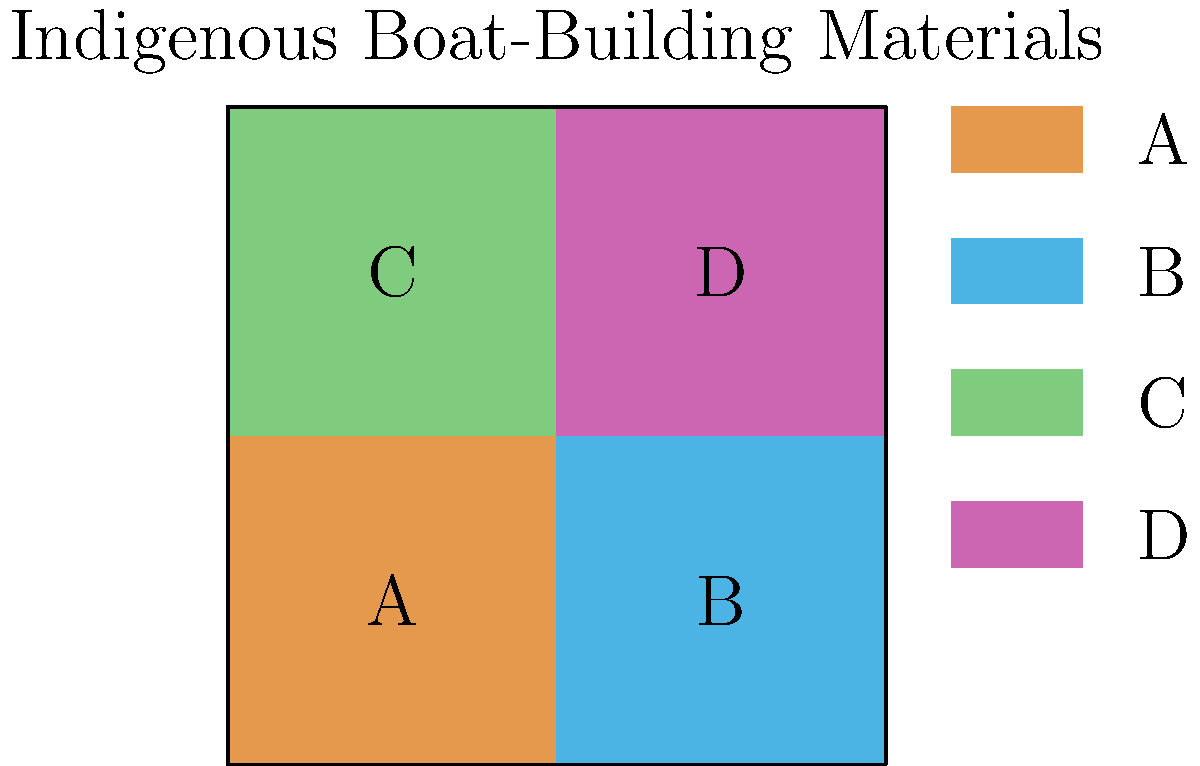Analyze the color-coded map representing the distribution of primary boat-building materials across four indigenous cultures (A, B, C, and D). If you were to calculate the Shannon diversity index ($H'$) for this distribution, which culture would contribute the most to the overall diversity, assuming each color represents a unique material type? To determine which culture contributes most to the Shannon diversity index, we need to follow these steps:

1. Recall the Shannon diversity index formula:
   $H' = -\sum_{i=1}^{R} p_i \ln(p_i)$
   where $p_i$ is the proportion of individuals belonging to the $i$-th species.

2. In this case, each culture (A, B, C, D) represents a "species" in the diversity calculation.

3. Observe that each culture uses a different material (color), so they all have equal proportions:
   $p_A = p_B = p_C = p_D = \frac{1}{4}$

4. Calculate the contribution of each culture to $H'$:
   $-p_i \ln(p_i) = -\frac{1}{4} \ln(\frac{1}{4}) \approx 0.3466$

5. Since all cultures have the same proportion, they all contribute equally to the diversity index.

6. However, the question asks which culture would contribute the most. In diversity studies, unique or rare species (or in this case, materials) are often considered more valuable for diversity.

7. Looking at the map, we can see that culture B (light blue) is the only one using its particular material in the upper-right quadrant.

8. This uniqueness in spatial distribution makes culture B's material potentially more significant for overall diversity, even though mathematically all cultures contribute equally to the Shannon index.
Answer: Culture B 